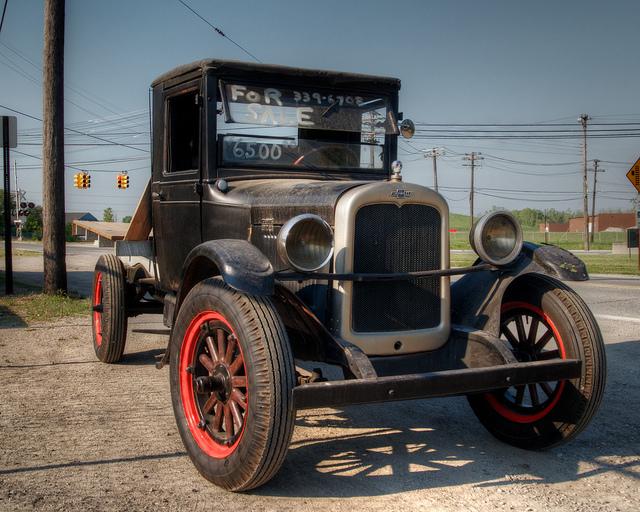Who ride this?
Give a very brief answer. Man. What do the words read?
Short answer required. For sale. Is the car for sale at a good price?
Write a very short answer. Yes. Is the sky clear?
Keep it brief. Yes. What kind of vehicle is that?
Concise answer only. Car. 